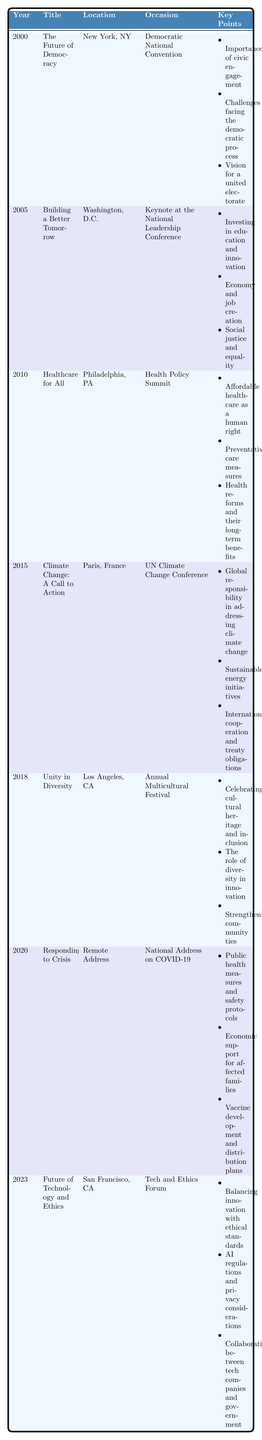What was the title of the speech given in 2005? The table lists the titles of all speeches by year. In 2005, the title is "Building a Better Tomorrow."
Answer: Building a Better Tomorrow In which city was the speech "Healthcare for All" delivered? Looking at the table, the location for the 2010 speech "Healthcare for All" is Philadelphia, PA.
Answer: Philadelphia, PA How many speeches were given at international locations? The table shows locations for each speech. The speeches in international locations are: "Climate Change: A Call to Action" (Paris, France) and "Future of Technology and Ethics" (San Francisco, CA). Therefore, there are 2 international speeches.
Answer: 2 What occasion was the speech "Unity in Diversity" given? The occasion listed for the 2018 speech "Unity in Diversity" is the "Annual Multicultural Festival."
Answer: Annual Multicultural Festival Was there a speech addressing public health measures in response to a crisis? The table includes a speech titled "Responding to Crisis" in 2020, specifically addressing public health measures related to COVID-19.
Answer: Yes Which speech focused on economic support during a national crisis? The 2020 speech "Responding to Crisis" mentions economic support for affected families due to COVID-19, indicating its focus on economic support during a national crisis.
Answer: Responding to Crisis What is the primary theme discussed in the speech delivered in 2015? The speech in 2015 titled "Climate Change: A Call to Action" covers the global responsibility, sustainable initiatives, and international cooperation, indicating a primary theme of environmental concern.
Answer: Environmental concern What year saw a focus on healthcare and human rights? The table states that the speech "Healthcare for All" was delivered in 2010, focusing on affordable healthcare as a human right.
Answer: 2010 Which speech emphasized the importance of civic engagement? In 2000, the speech titled "The Future of Democracy" emphasized civic engagement as one of its key points.
Answer: The Future of Democracy Which two key points were mentioned in the 2018 speech? The table shows that the 2018 speech "Unity in Diversity" mentions celebrating cultural heritage and the role of diversity in innovation as two key points.
Answer: Celebrating cultural heritage and the role of diversity in innovation List the key issue addressed in the 2023 speech concerning technology. The 2023 speech "Future of Technology and Ethics" discusses balancing innovation with ethical standards, AI regulations, and collaboration between tech companies and government. The key issue addressed is balancing innovation with ethics.
Answer: Balancing innovation with ethics How many speeches discuss issues related to equality and social justice? The table indicates that the 2005 speech "Building a Better Tomorrow" focuses on social justice and equality; therefore, there is one speech addressing these issues.
Answer: 1 What can be inferred about the political leader's priorities over the years? By examining the table, one can infer that the leader has prioritized various social issues over the years, such as democracy, healthcare, climate change, cultural diversity, public health, and technology ethics. This suggests a broad set of commitments to social, environmental, and technological issues.
Answer: Broad set of commitments to social, environmental, and technological issues 